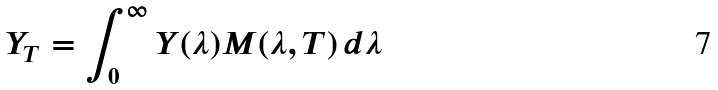<formula> <loc_0><loc_0><loc_500><loc_500>Y _ { T } = \int _ { 0 } ^ { \infty } Y ( \lambda ) M ( \lambda , T ) \, d \lambda</formula> 